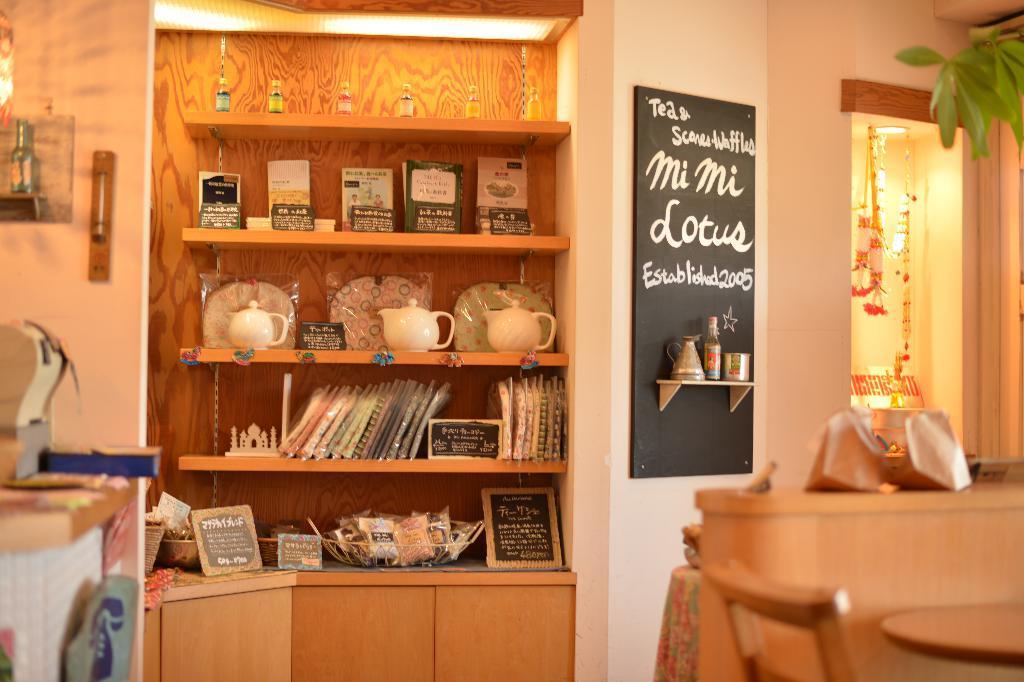In one or two sentences, can you explain what this image depicts? On the left side, there are some objects on the table. On the right side, there are some objects on the table near a chair. In the background, there are plates, vessels, pots, books, bottles, frames and other objects arranged on the shelves. There is a hoarding attached to the wall, there is a bottle, jug and a glass on the shelf, there are lights arranged, there is a plant and there is wall. 